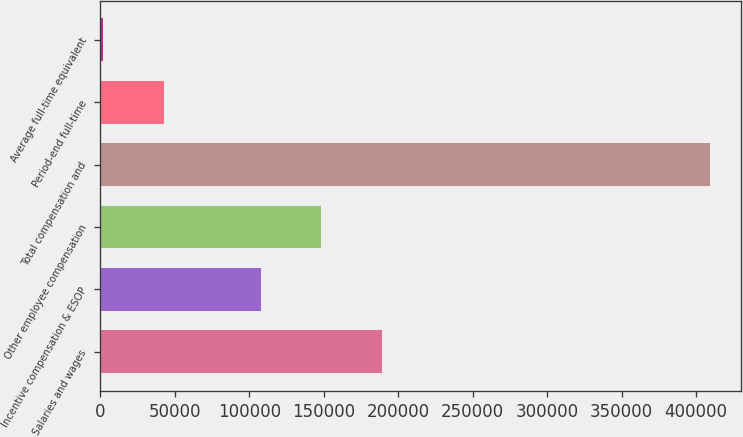<chart> <loc_0><loc_0><loc_500><loc_500><bar_chart><fcel>Salaries and wages<fcel>Incentive compensation & ESOP<fcel>Other employee compensation<fcel>Total compensation and<fcel>Period-end full-time<fcel>Average full-time equivalent<nl><fcel>189098<fcel>107564<fcel>148331<fcel>409486<fcel>42582.1<fcel>1815<nl></chart> 